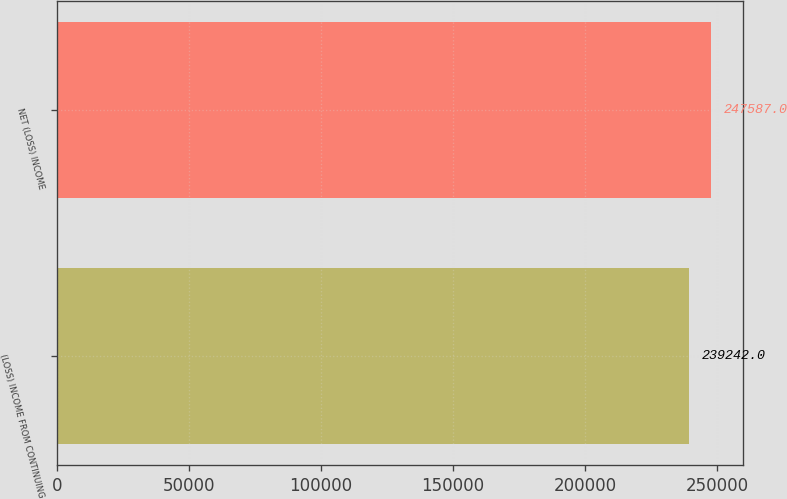Convert chart. <chart><loc_0><loc_0><loc_500><loc_500><bar_chart><fcel>(LOSS) INCOME FROM CONTINUING<fcel>NET (LOSS) INCOME<nl><fcel>239242<fcel>247587<nl></chart> 